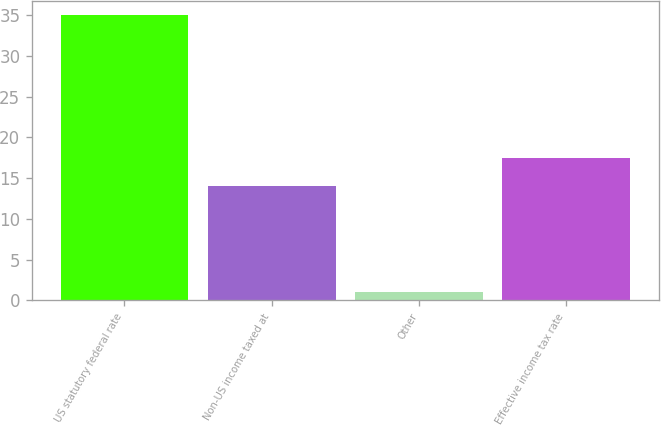<chart> <loc_0><loc_0><loc_500><loc_500><bar_chart><fcel>US statutory federal rate<fcel>Non-US income taxed at<fcel>Other<fcel>Effective income tax rate<nl><fcel>35<fcel>14<fcel>1<fcel>17.4<nl></chart> 